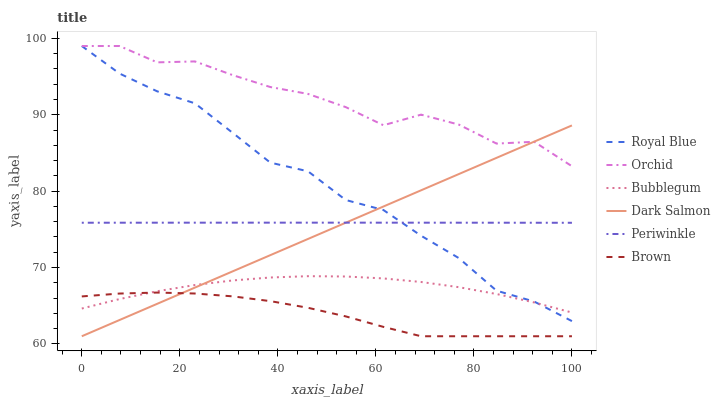Does Brown have the minimum area under the curve?
Answer yes or no. Yes. Does Orchid have the maximum area under the curve?
Answer yes or no. Yes. Does Dark Salmon have the minimum area under the curve?
Answer yes or no. No. Does Dark Salmon have the maximum area under the curve?
Answer yes or no. No. Is Dark Salmon the smoothest?
Answer yes or no. Yes. Is Orchid the roughest?
Answer yes or no. Yes. Is Bubblegum the smoothest?
Answer yes or no. No. Is Bubblegum the roughest?
Answer yes or no. No. Does Brown have the lowest value?
Answer yes or no. Yes. Does Bubblegum have the lowest value?
Answer yes or no. No. Does Orchid have the highest value?
Answer yes or no. Yes. Does Dark Salmon have the highest value?
Answer yes or no. No. Is Bubblegum less than Orchid?
Answer yes or no. Yes. Is Orchid greater than Periwinkle?
Answer yes or no. Yes. Does Brown intersect Dark Salmon?
Answer yes or no. Yes. Is Brown less than Dark Salmon?
Answer yes or no. No. Is Brown greater than Dark Salmon?
Answer yes or no. No. Does Bubblegum intersect Orchid?
Answer yes or no. No. 